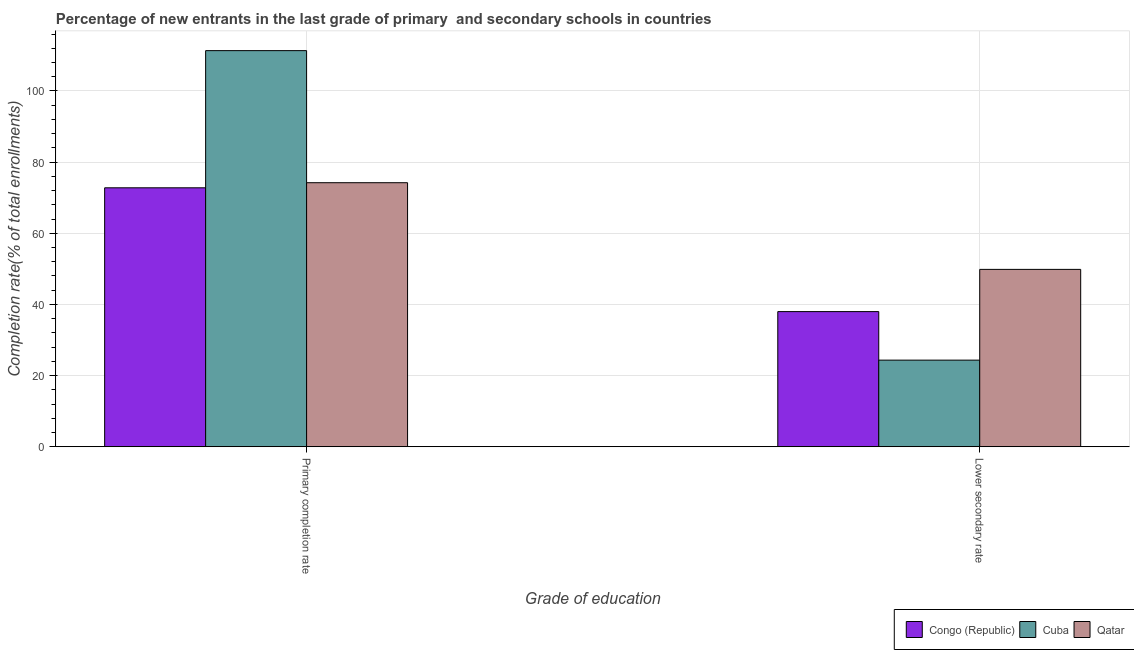How many groups of bars are there?
Make the answer very short. 2. Are the number of bars per tick equal to the number of legend labels?
Ensure brevity in your answer.  Yes. How many bars are there on the 1st tick from the left?
Give a very brief answer. 3. What is the label of the 1st group of bars from the left?
Offer a terse response. Primary completion rate. What is the completion rate in secondary schools in Congo (Republic)?
Your answer should be compact. 37.99. Across all countries, what is the maximum completion rate in secondary schools?
Your answer should be very brief. 49.85. Across all countries, what is the minimum completion rate in primary schools?
Keep it short and to the point. 72.78. In which country was the completion rate in secondary schools maximum?
Provide a succinct answer. Qatar. In which country was the completion rate in primary schools minimum?
Give a very brief answer. Congo (Republic). What is the total completion rate in secondary schools in the graph?
Make the answer very short. 112.18. What is the difference between the completion rate in secondary schools in Cuba and that in Qatar?
Provide a short and direct response. -25.51. What is the difference between the completion rate in primary schools in Cuba and the completion rate in secondary schools in Congo (Republic)?
Your answer should be very brief. 73.36. What is the average completion rate in secondary schools per country?
Your answer should be compact. 37.39. What is the difference between the completion rate in secondary schools and completion rate in primary schools in Cuba?
Give a very brief answer. -87. In how many countries, is the completion rate in primary schools greater than 12 %?
Keep it short and to the point. 3. What is the ratio of the completion rate in primary schools in Congo (Republic) to that in Cuba?
Ensure brevity in your answer.  0.65. In how many countries, is the completion rate in primary schools greater than the average completion rate in primary schools taken over all countries?
Give a very brief answer. 1. What does the 1st bar from the left in Primary completion rate represents?
Your answer should be compact. Congo (Republic). What does the 2nd bar from the right in Lower secondary rate represents?
Ensure brevity in your answer.  Cuba. Are all the bars in the graph horizontal?
Provide a succinct answer. No. How many countries are there in the graph?
Ensure brevity in your answer.  3. Does the graph contain grids?
Your response must be concise. Yes. Where does the legend appear in the graph?
Keep it short and to the point. Bottom right. How are the legend labels stacked?
Offer a very short reply. Horizontal. What is the title of the graph?
Your answer should be very brief. Percentage of new entrants in the last grade of primary  and secondary schools in countries. What is the label or title of the X-axis?
Ensure brevity in your answer.  Grade of education. What is the label or title of the Y-axis?
Ensure brevity in your answer.  Completion rate(% of total enrollments). What is the Completion rate(% of total enrollments) in Congo (Republic) in Primary completion rate?
Provide a succinct answer. 72.78. What is the Completion rate(% of total enrollments) in Cuba in Primary completion rate?
Keep it short and to the point. 111.34. What is the Completion rate(% of total enrollments) of Qatar in Primary completion rate?
Your answer should be very brief. 74.22. What is the Completion rate(% of total enrollments) in Congo (Republic) in Lower secondary rate?
Keep it short and to the point. 37.99. What is the Completion rate(% of total enrollments) of Cuba in Lower secondary rate?
Your response must be concise. 24.34. What is the Completion rate(% of total enrollments) in Qatar in Lower secondary rate?
Make the answer very short. 49.85. Across all Grade of education, what is the maximum Completion rate(% of total enrollments) in Congo (Republic)?
Give a very brief answer. 72.78. Across all Grade of education, what is the maximum Completion rate(% of total enrollments) in Cuba?
Ensure brevity in your answer.  111.34. Across all Grade of education, what is the maximum Completion rate(% of total enrollments) in Qatar?
Keep it short and to the point. 74.22. Across all Grade of education, what is the minimum Completion rate(% of total enrollments) in Congo (Republic)?
Offer a very short reply. 37.99. Across all Grade of education, what is the minimum Completion rate(% of total enrollments) in Cuba?
Your answer should be very brief. 24.34. Across all Grade of education, what is the minimum Completion rate(% of total enrollments) of Qatar?
Provide a succinct answer. 49.85. What is the total Completion rate(% of total enrollments) in Congo (Republic) in the graph?
Provide a succinct answer. 110.77. What is the total Completion rate(% of total enrollments) of Cuba in the graph?
Offer a very short reply. 135.68. What is the total Completion rate(% of total enrollments) in Qatar in the graph?
Your response must be concise. 124.07. What is the difference between the Completion rate(% of total enrollments) in Congo (Republic) in Primary completion rate and that in Lower secondary rate?
Your answer should be compact. 34.8. What is the difference between the Completion rate(% of total enrollments) of Cuba in Primary completion rate and that in Lower secondary rate?
Your response must be concise. 87. What is the difference between the Completion rate(% of total enrollments) of Qatar in Primary completion rate and that in Lower secondary rate?
Offer a terse response. 24.37. What is the difference between the Completion rate(% of total enrollments) of Congo (Republic) in Primary completion rate and the Completion rate(% of total enrollments) of Cuba in Lower secondary rate?
Make the answer very short. 48.44. What is the difference between the Completion rate(% of total enrollments) in Congo (Republic) in Primary completion rate and the Completion rate(% of total enrollments) in Qatar in Lower secondary rate?
Give a very brief answer. 22.93. What is the difference between the Completion rate(% of total enrollments) of Cuba in Primary completion rate and the Completion rate(% of total enrollments) of Qatar in Lower secondary rate?
Ensure brevity in your answer.  61.49. What is the average Completion rate(% of total enrollments) of Congo (Republic) per Grade of education?
Offer a terse response. 55.38. What is the average Completion rate(% of total enrollments) in Cuba per Grade of education?
Make the answer very short. 67.84. What is the average Completion rate(% of total enrollments) of Qatar per Grade of education?
Your answer should be compact. 62.03. What is the difference between the Completion rate(% of total enrollments) of Congo (Republic) and Completion rate(% of total enrollments) of Cuba in Primary completion rate?
Provide a succinct answer. -38.56. What is the difference between the Completion rate(% of total enrollments) in Congo (Republic) and Completion rate(% of total enrollments) in Qatar in Primary completion rate?
Make the answer very short. -1.43. What is the difference between the Completion rate(% of total enrollments) in Cuba and Completion rate(% of total enrollments) in Qatar in Primary completion rate?
Keep it short and to the point. 37.13. What is the difference between the Completion rate(% of total enrollments) of Congo (Republic) and Completion rate(% of total enrollments) of Cuba in Lower secondary rate?
Your answer should be very brief. 13.65. What is the difference between the Completion rate(% of total enrollments) in Congo (Republic) and Completion rate(% of total enrollments) in Qatar in Lower secondary rate?
Offer a terse response. -11.87. What is the difference between the Completion rate(% of total enrollments) of Cuba and Completion rate(% of total enrollments) of Qatar in Lower secondary rate?
Your response must be concise. -25.51. What is the ratio of the Completion rate(% of total enrollments) of Congo (Republic) in Primary completion rate to that in Lower secondary rate?
Offer a terse response. 1.92. What is the ratio of the Completion rate(% of total enrollments) of Cuba in Primary completion rate to that in Lower secondary rate?
Your answer should be compact. 4.57. What is the ratio of the Completion rate(% of total enrollments) in Qatar in Primary completion rate to that in Lower secondary rate?
Offer a very short reply. 1.49. What is the difference between the highest and the second highest Completion rate(% of total enrollments) in Congo (Republic)?
Your response must be concise. 34.8. What is the difference between the highest and the second highest Completion rate(% of total enrollments) in Cuba?
Your response must be concise. 87. What is the difference between the highest and the second highest Completion rate(% of total enrollments) in Qatar?
Ensure brevity in your answer.  24.37. What is the difference between the highest and the lowest Completion rate(% of total enrollments) in Congo (Republic)?
Give a very brief answer. 34.8. What is the difference between the highest and the lowest Completion rate(% of total enrollments) of Cuba?
Provide a succinct answer. 87. What is the difference between the highest and the lowest Completion rate(% of total enrollments) in Qatar?
Offer a terse response. 24.37. 